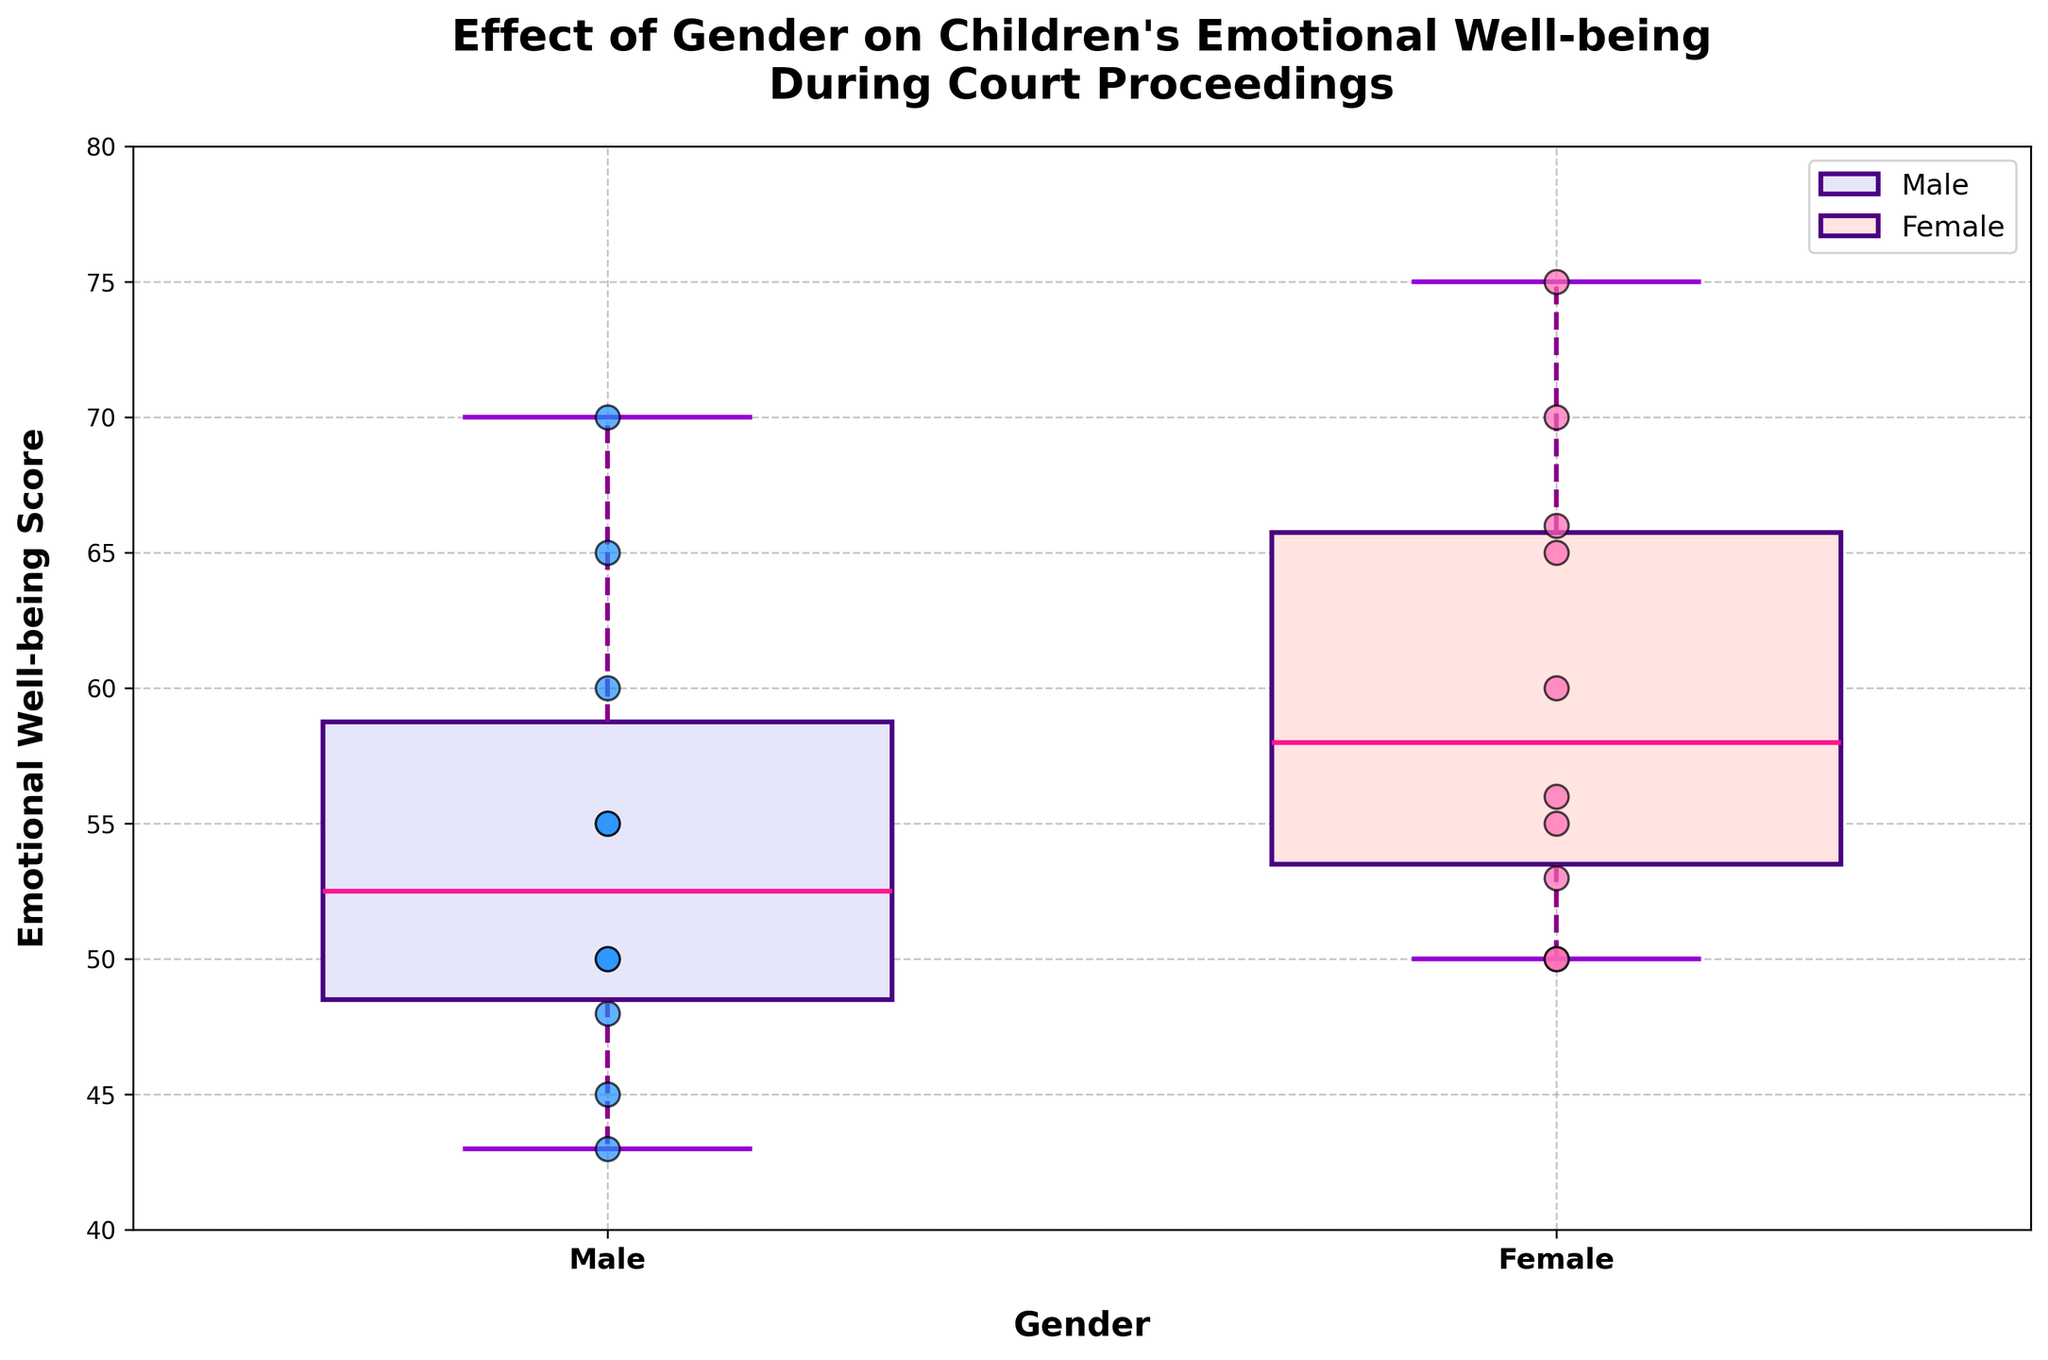How many scatter points are there in the plot for male children? By observing the scatter points for the male category, we count the number of points present.
Answer: 10 How is the range of emotional well-being scores for female children different from male children? The range can be found by subtracting the smallest score from the largest score in each category. For males, the range is 70 - 43 = 27. For females, the range is 75 - 50 = 25.
Answer: The range for males is 27 and for females is 25 What is the median emotional well-being score for female children? The median is a vertical line in the middle of the box plot. For females, observe the middle line inside the box plot.
Answer: 60 Which gender has a lower median emotional well-being score? By comparing the median lines inside the box plots, the lower median can be identified. The median for males is 52.5 and for females is 60.
Answer: Male How do the interquartile ranges (IQRs) for males and females compare? The IQR is the range within the box itself (the distance between the 25th and 75th percentiles). For males, this can be seen between 48 and 60; for females, between 53 and 70. Calculate IQR for both: Males: 60 - 48 = 12; Females: 70 - 53 = 17.
Answer: The IQR for males is 12 and for females is 17 Are male emotional well-being scores more spread out than female scores? Spread can be observed by looking at the whiskers and the range of points. Males have scores ranging from 43 to 70, while females have scores ranging from 50 to 75.
Answer: No, female scores are more spread out What is the effect on emotional well-being scores as the length of court proceedings increases for males? By observing the scatter points for males, notice the trend in the data as it moves left to right. Scores generally decrease as the length of court proceedings increases.
Answer: Emotional well-being scores decrease Which group - male or female - has more higher emotional well-being scores? Count the number of data points above a certain threshold. Observing the data, females have more points above 60 than males.
Answer: Female What is the emotional well-being score interquartile range (IQR) for female children? The IQR range for females can be found by finding the difference between the upper and lower quartiles (75th percentile and 25th percentile). For females: IQR = 70 - 53 = 17.
Answer: 17 